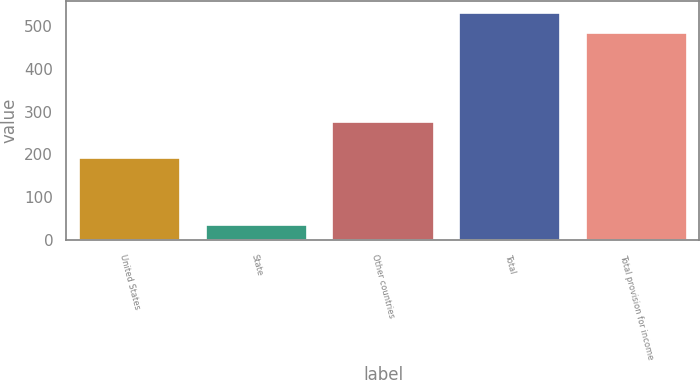Convert chart to OTSL. <chart><loc_0><loc_0><loc_500><loc_500><bar_chart><fcel>United States<fcel>State<fcel>Other countries<fcel>Total<fcel>Total provision for income<nl><fcel>192<fcel>35.4<fcel>275.9<fcel>530.69<fcel>483.9<nl></chart> 